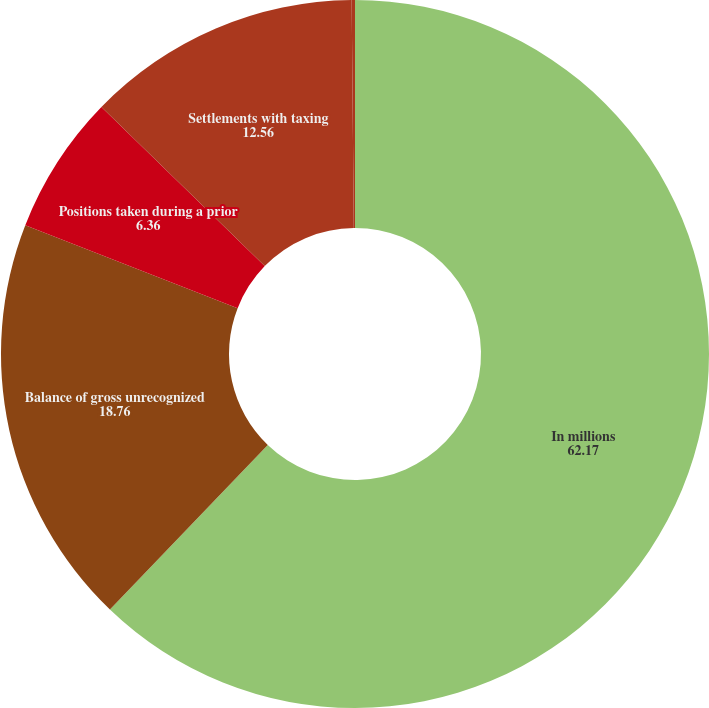Convert chart. <chart><loc_0><loc_0><loc_500><loc_500><pie_chart><fcel>In millions<fcel>Balance of gross unrecognized<fcel>Positions taken during a prior<fcel>Settlements with taxing<fcel>Reductions resulting from<nl><fcel>62.17%<fcel>18.76%<fcel>6.36%<fcel>12.56%<fcel>0.15%<nl></chart> 